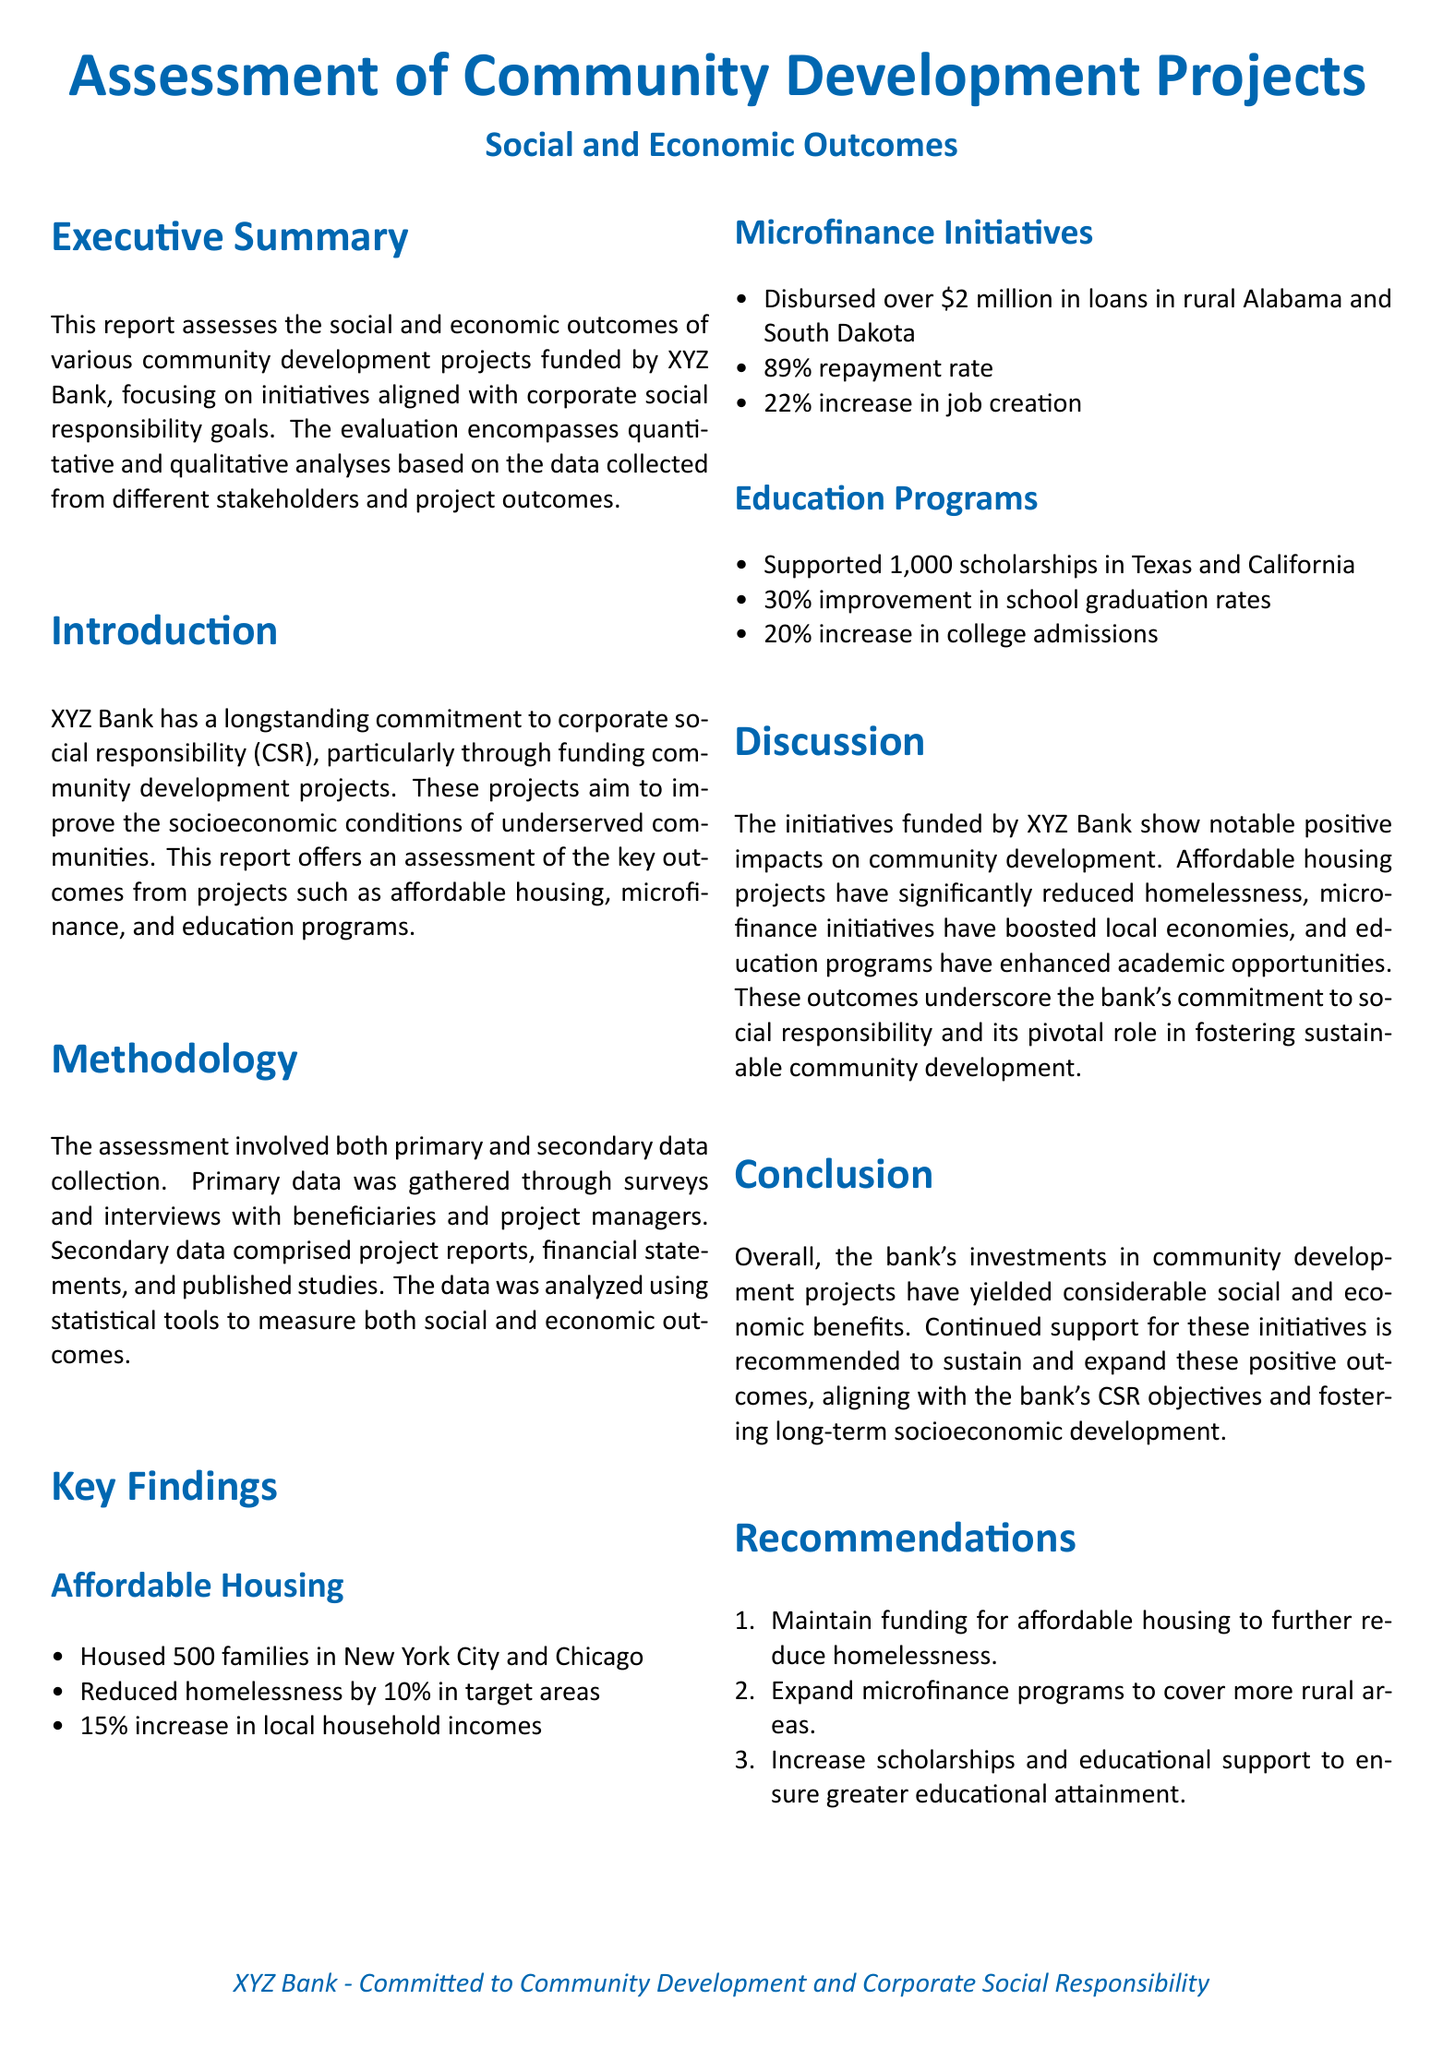What is the total number of families housed? The document states that 500 families were housed in New York City and Chicago under the affordable housing project.
Answer: 500 families What percentage reduction in homelessness was achieved? The report indicates that there was a 10% reduction in homelessness in target areas.
Answer: 10% How much funding was disbursed in microfinance initiatives? The microfinance section mentions that over $2 million in loans were disbursed in rural areas.
Answer: Over $2 million What was the job creation increase from microfinance? The report details a 22% increase in job creation as a result of microfinance initiatives.
Answer: 22% How many scholarships were supported in education programs? The education programs section mentions that 1,000 scholarships were supported in Texas and California.
Answer: 1,000 scholarships What was the improvement in school graduation rates? The document states that there was a 30% improvement in school graduation rates from the education programs.
Answer: 30% What is one recommendation made in the report? The recommendations section suggests maintaining funding for affordable housing to further reduce homelessness.
Answer: Maintain funding for affordable housing What does the report assess? The report assesses the social and economic outcomes of various community development projects funded by XYZ Bank.
Answer: Social and economic outcomes What indicates the bank's commitment to CSR? The document discusses initiatives that align with corporate social responsibility goals, showcasing the bank's dedication.
Answer: Corporate social responsibility goals 